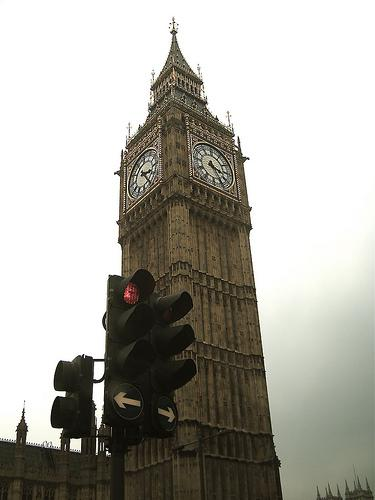Question: what color face does the clock have?
Choices:
A. Black.
B. Blue.
C. White.
D. Grey.
Answer with the letter. Answer: C Question: where is this clock located?
Choices:
A. New York.
B. Washington.
C. London.
D. Boston.
Answer with the letter. Answer: C 